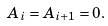<formula> <loc_0><loc_0><loc_500><loc_500>A _ { i } = A _ { i + 1 } = 0 .</formula> 